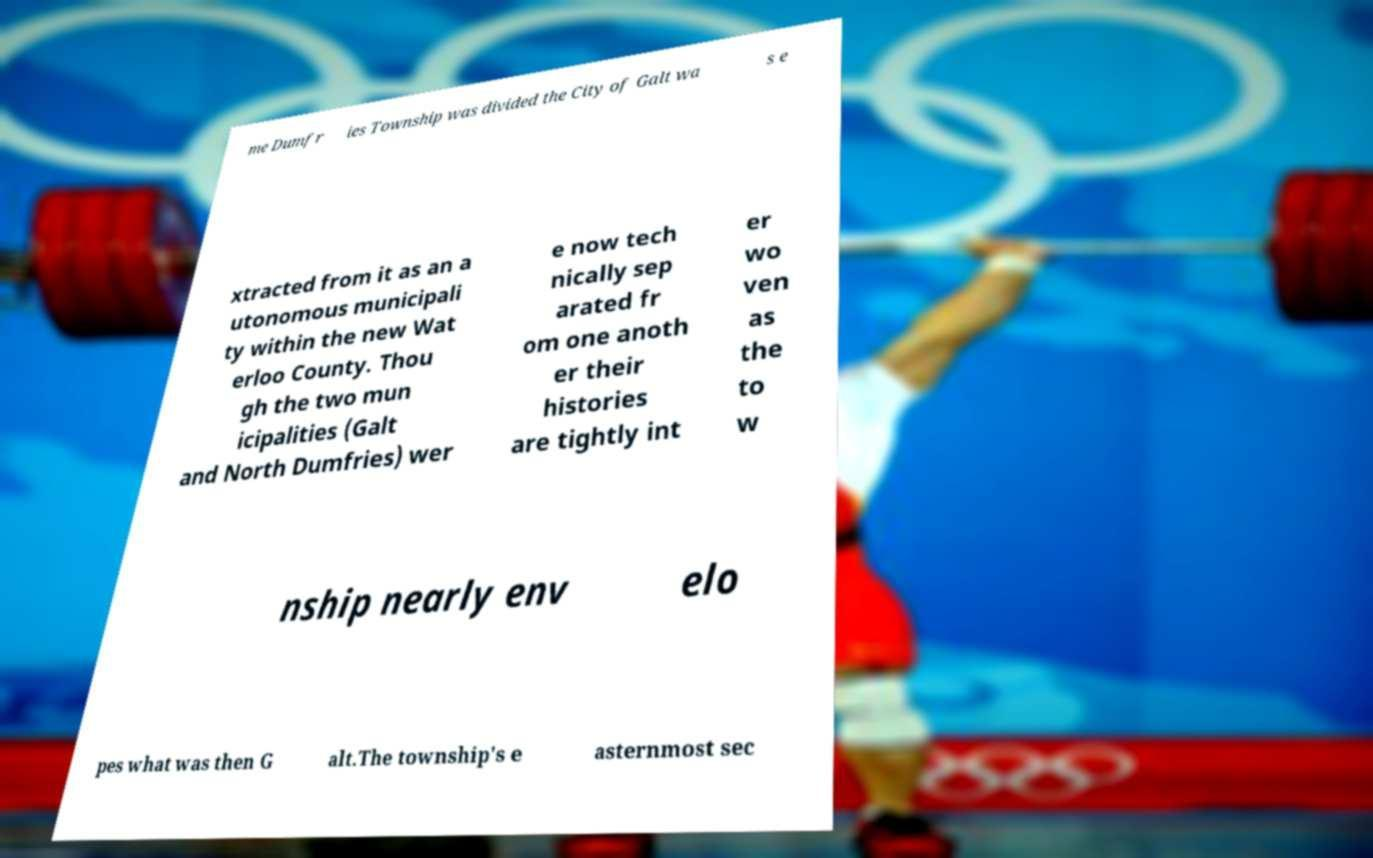What messages or text are displayed in this image? I need them in a readable, typed format. me Dumfr ies Township was divided the City of Galt wa s e xtracted from it as an a utonomous municipali ty within the new Wat erloo County. Thou gh the two mun icipalities (Galt and North Dumfries) wer e now tech nically sep arated fr om one anoth er their histories are tightly int er wo ven as the to w nship nearly env elo pes what was then G alt.The township's e asternmost sec 